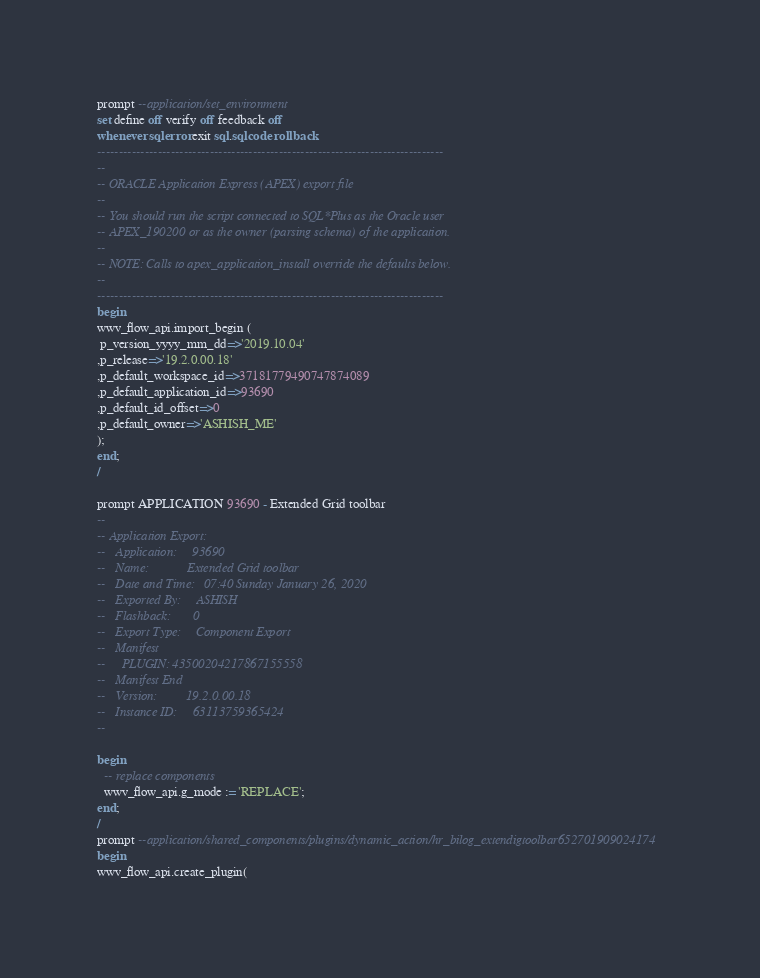<code> <loc_0><loc_0><loc_500><loc_500><_SQL_>prompt --application/set_environment
set define off verify off feedback off
whenever sqlerror exit sql.sqlcode rollback
--------------------------------------------------------------------------------
--
-- ORACLE Application Express (APEX) export file
--
-- You should run the script connected to SQL*Plus as the Oracle user
-- APEX_190200 or as the owner (parsing schema) of the application.
--
-- NOTE: Calls to apex_application_install override the defaults below.
--
--------------------------------------------------------------------------------
begin
wwv_flow_api.import_begin (
 p_version_yyyy_mm_dd=>'2019.10.04'
,p_release=>'19.2.0.00.18'
,p_default_workspace_id=>37181779490747874089
,p_default_application_id=>93690
,p_default_id_offset=>0
,p_default_owner=>'ASHISH_ME'
);
end;
/
 
prompt APPLICATION 93690 - Extended Grid toolbar
--
-- Application Export:
--   Application:     93690
--   Name:            Extended Grid toolbar
--   Date and Time:   07:40 Sunday January 26, 2020
--   Exported By:     ASHISH
--   Flashback:       0
--   Export Type:     Component Export
--   Manifest
--     PLUGIN: 43500204217867155558
--   Manifest End
--   Version:         19.2.0.00.18
--   Instance ID:     63113759365424
--

begin
  -- replace components
  wwv_flow_api.g_mode := 'REPLACE';
end;
/
prompt --application/shared_components/plugins/dynamic_action/hr_bilog_extendigtoolbar652701909024174
begin
wwv_flow_api.create_plugin(</code> 